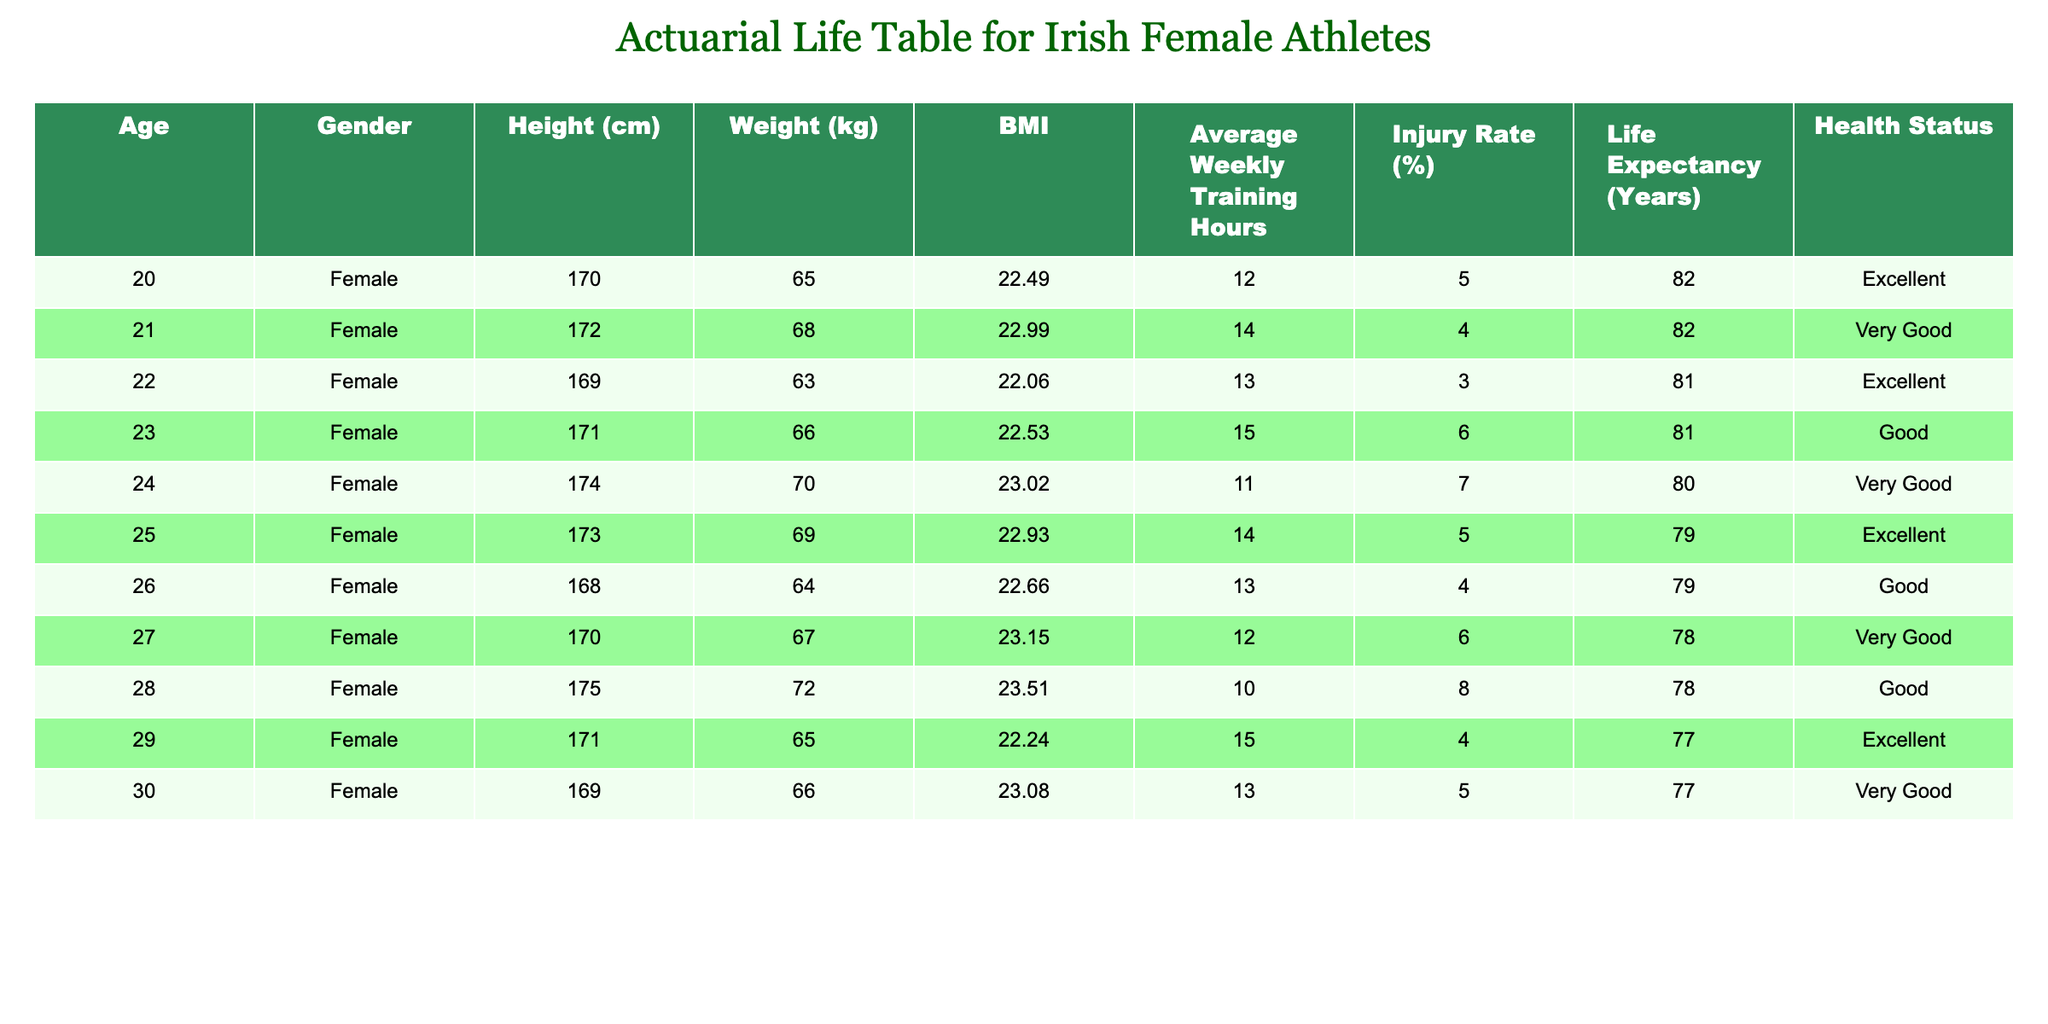What is the life expectancy of a 25-year-old female athlete? According to the table, the life expectancy listed for a 25-year-old female athlete is 79 years.
Answer: 79 years What is the average BMI of athletes aged 20 to 25? To calculate the average BMI for ages 20 to 25, we sum their BMI values: 22.49 + 22.99 + 22.06 + 22.53 + 23.02 = 113.09. Dividing by the 6 athletes gives an average of 113.09/6 = 18.85.
Answer: 18.85 Is there a higher injury rate for athletes aged 28 compared to those aged 25? The injury rate for a 28-year-old female athlete is 8%, while for a 25-year-old is 5%. Since 8% is greater than 5%, the statement is true.
Answer: Yes What health status is most common for athletes aged 26 to 30? The health statuses for ages 26 to 30 are: Good, Very Good, Excellent, Very Good. Counting these reveals that "Very Good" appears twice, while "Good" and "Excellent" appear once. Thus, "Very Good" is the most common.
Answer: Very Good What is the average height of athletes aged 21 to 24? The heights for ages 21 to 24 are: 172, 169, 174, and 173 cm. Sum these values (172 + 169 + 174 + 173 = 688) and divide by 4 to find the average: 688/4 = 172.
Answer: 172 cm Does the average weekly training hours increase or decrease from age 20 to 29? At age 20, average weekly training hours are 12, and at age 29, they are 15. Since 15 is greater than 12, this indicates an increase.
Answer: Increase What percentage of athletes aged 23 and older have a health status of "Excellent"? The athletes aged 23 and older are 23, 24, 25, 26, 27, 28, 29, and 30. Among these, the health statuses are: Good, Very Good, Excellent, Good, Very Good, Good, Excellent, Very Good. Only 2 out of 8 athletes have "Excellent" health status. Therefore, the percentage is (2/8)*100 = 25%.
Answer: 25% Which age group has the lowest average weight? The ages to consider are 20 (65 kg), 21 (68 kg), 22 (63 kg), 23 (66 kg), 24 (70 kg), 25 (69 kg), 26 (64 kg), 27 (67 kg), 28 (72 kg), 29 (65 kg), and 30 (66 kg). The lowest weight is 63 kg for age 22.
Answer: 22 years old (63 kg) How do the average injury rates for ages 20 to 25 compare to those for ages 26 to 30? For ages 20 to 25, the injury rates are 5, 4, 3, 6, 7, and 5%, which averages to (5+4+3+6+7+5)/6 = 5%. For ages 26 to 30, the rates are 4, 6, 8, 4, and 5%, averaging to (4+6+8+4+5)/5 = 5.4%. Thus, the average injury rate for 26-30 is higher than for 20-25.
Answer: 26 to 30 is higher 